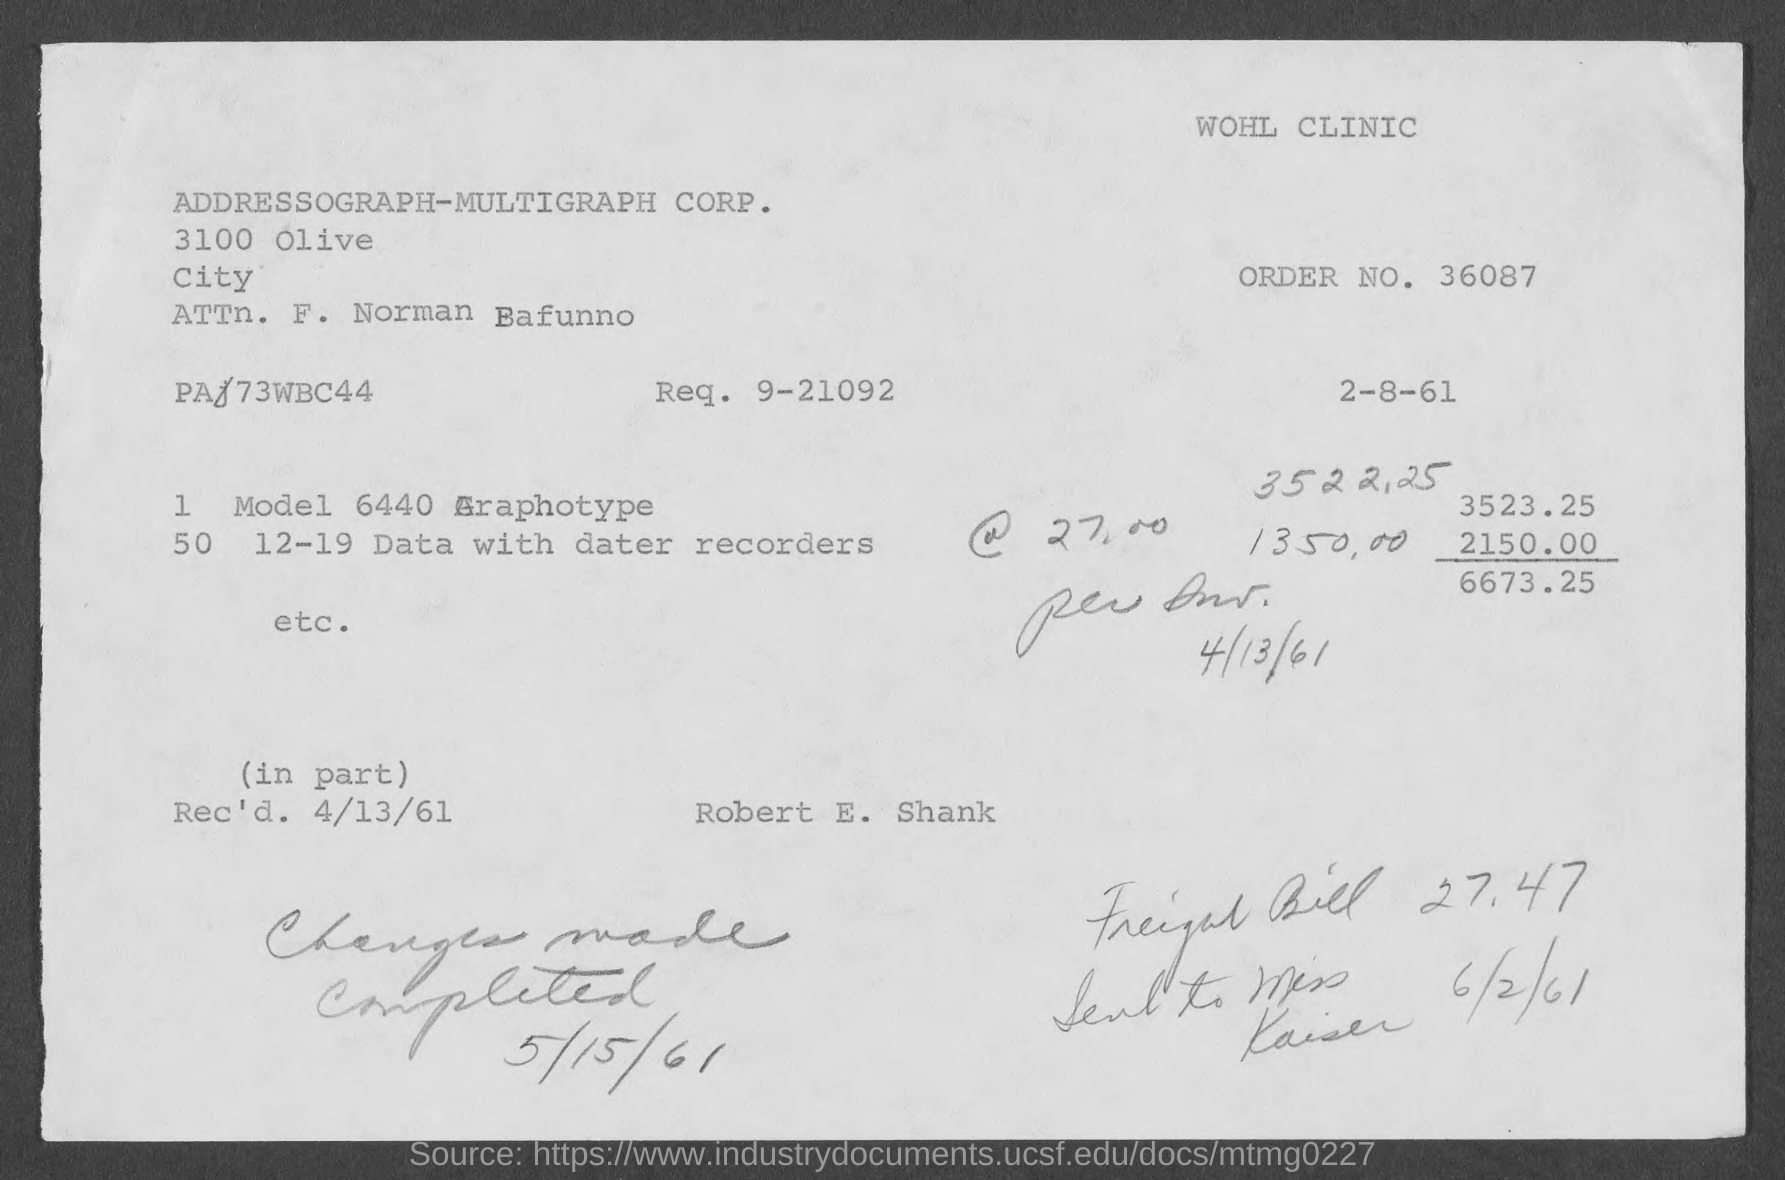What is the order no.?
Provide a short and direct response. 36087. What is the req. no?
Your answer should be very brief. 9-21092. What is the attn. person name?
Make the answer very short. F. Norman Bafunno. 